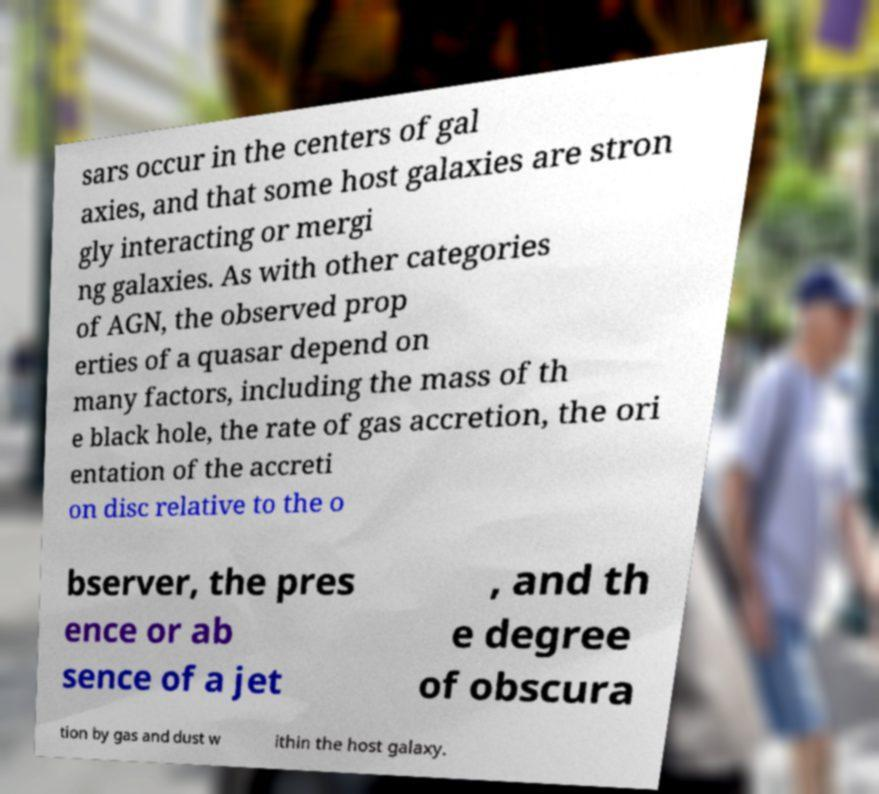Please read and relay the text visible in this image. What does it say? sars occur in the centers of gal axies, and that some host galaxies are stron gly interacting or mergi ng galaxies. As with other categories of AGN, the observed prop erties of a quasar depend on many factors, including the mass of th e black hole, the rate of gas accretion, the ori entation of the accreti on disc relative to the o bserver, the pres ence or ab sence of a jet , and th e degree of obscura tion by gas and dust w ithin the host galaxy. 